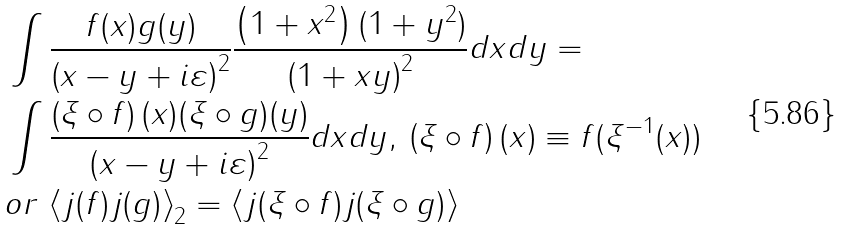Convert formula to latex. <formula><loc_0><loc_0><loc_500><loc_500>& \int \frac { f ( x ) g ( y ) } { \left ( x - y + i \varepsilon \right ) ^ { 2 } } \frac { \left ( 1 + x ^ { 2 } \right ) ( 1 + y ^ { 2 } ) } { \left ( 1 + x y \right ) ^ { 2 } } d x d y = \\ & \int \frac { \left ( \xi \circ f \right ) ( x ) ( \xi \circ g ) ( y ) } { \left ( x - y + i \varepsilon \right ) ^ { 2 } } d x d y , \, \left ( \xi \circ f \right ) ( x ) \equiv f ( \xi ^ { - 1 } ( x ) ) \\ & o r \, \left \langle j ( f ) j ( g ) \right \rangle _ { 2 } = \left \langle j ( \xi \circ f ) j ( \xi \circ g ) \right \rangle</formula> 